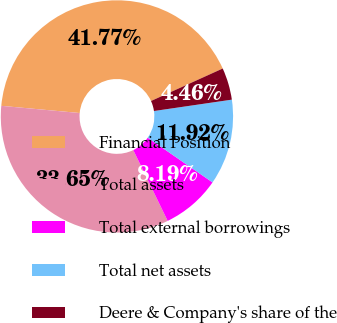<chart> <loc_0><loc_0><loc_500><loc_500><pie_chart><fcel>Financial Position<fcel>Total assets<fcel>Total external borrowings<fcel>Total net assets<fcel>Deere & Company's share of the<nl><fcel>41.77%<fcel>33.65%<fcel>8.19%<fcel>11.92%<fcel>4.46%<nl></chart> 